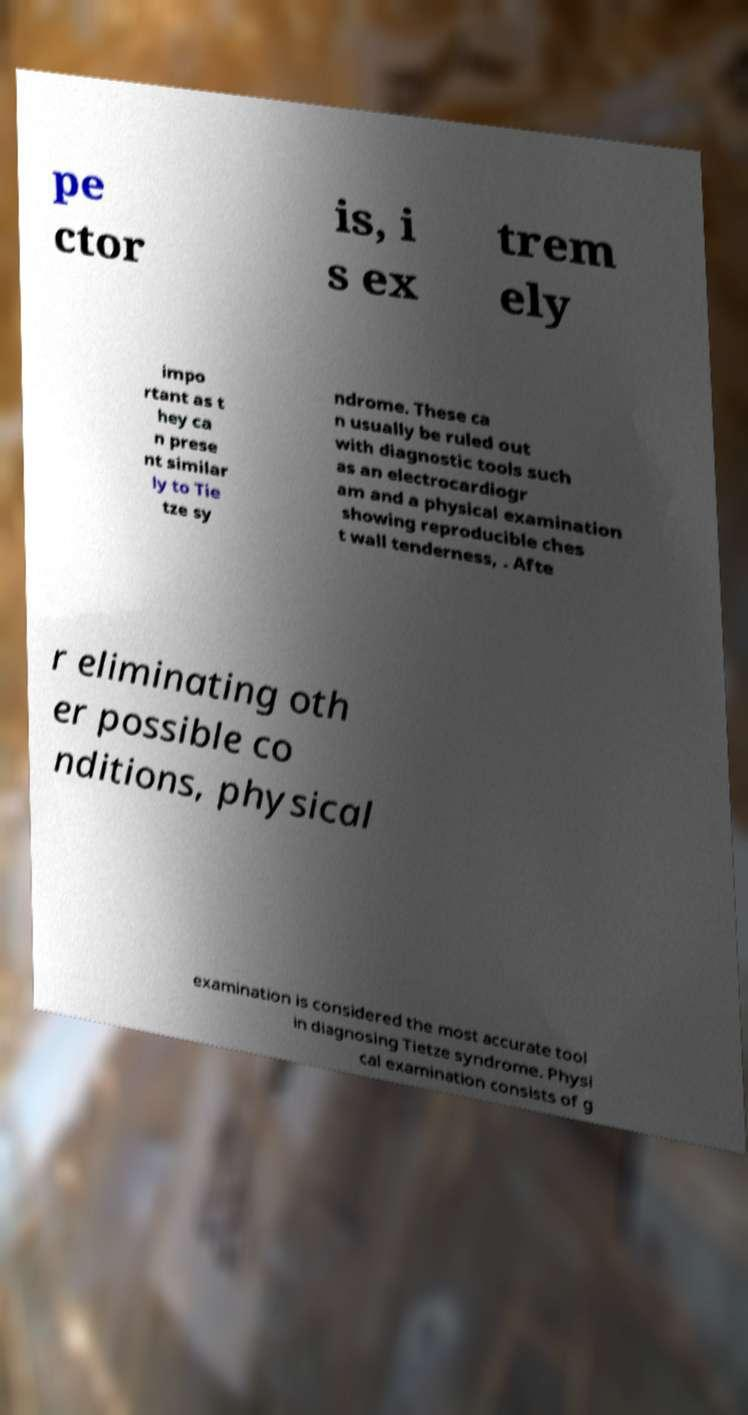I need the written content from this picture converted into text. Can you do that? pe ctor is, i s ex trem ely impo rtant as t hey ca n prese nt similar ly to Tie tze sy ndrome. These ca n usually be ruled out with diagnostic tools such as an electrocardiogr am and a physical examination showing reproducible ches t wall tenderness, . Afte r eliminating oth er possible co nditions, physical examination is considered the most accurate tool in diagnosing Tietze syndrome. Physi cal examination consists of g 